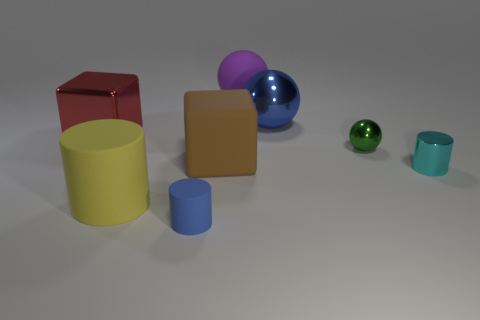What can you observe about the lighting in the scene? The lighting in the image appears to be diffuse and soft, likely from a source not visible in the frame or an environmental light source. Shadows are present but not sharply defined, suggesting an overcast or multi-directional lighting setup.  Does the image suggest an indoor or outdoor setting? The image seems to depict an indoor setting, possibly a studio or controlled environment for rendering objects. The uniform background and controlled lighting are typical for such settings where the focus is on the objects themselves and their characteristics. 